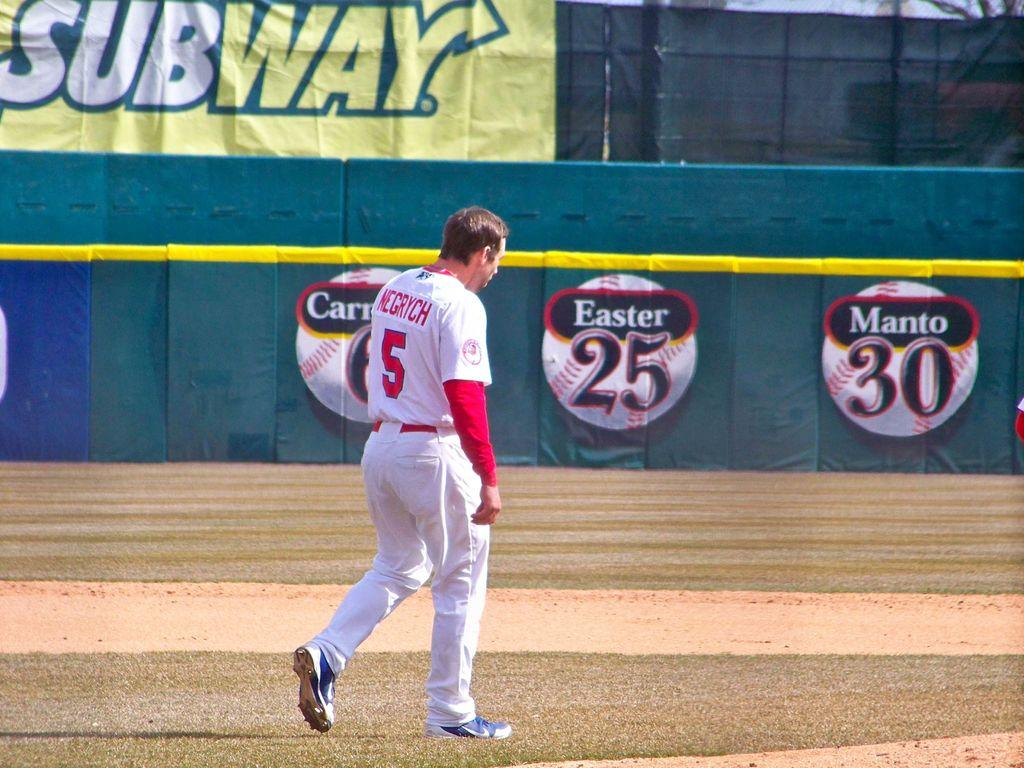<image>
Summarize the visual content of the image. Number 5 Negrych on the baseball field walking to the outfield. 